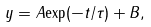<formula> <loc_0><loc_0><loc_500><loc_500>y = A { \exp } ( - t / \tau ) + B ,</formula> 